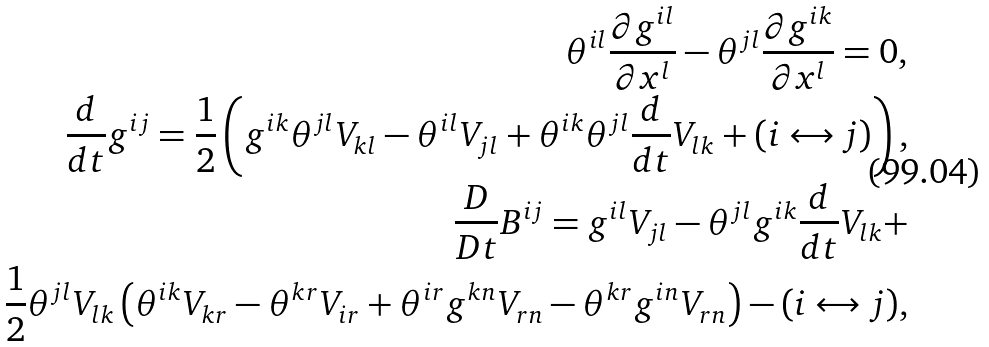<formula> <loc_0><loc_0><loc_500><loc_500>\theta ^ { i l } \frac { \partial g ^ { i l } } { \partial { x } ^ { l } } - \theta ^ { j l } \frac { \partial g ^ { i k } } { \partial x ^ { l } } = 0 , \\ \frac { d } { d t } g ^ { i j } = \frac { 1 } { 2 } \left ( g ^ { i k } \theta ^ { j l } V _ { k l } - \theta ^ { i l } V _ { j l } + \theta ^ { i k } \theta ^ { j l } \frac { d } { d t } V _ { l k } + ( i \leftrightarrow j ) \right ) , \\ \frac { D } { D t } B ^ { i j } = g ^ { i l } V _ { j l } - \theta ^ { j l } g ^ { i k } \frac { d } { d t } V _ { l k } + \\ \frac { 1 } { 2 } \theta ^ { j l } V _ { l k } \left ( \theta ^ { i k } V _ { k r } - \theta ^ { k r } V _ { i r } + \theta ^ { i r } g ^ { k n } V _ { r n } - \theta ^ { k r } g ^ { i n } V _ { r n } \right ) - ( i \leftrightarrow j ) ,</formula> 